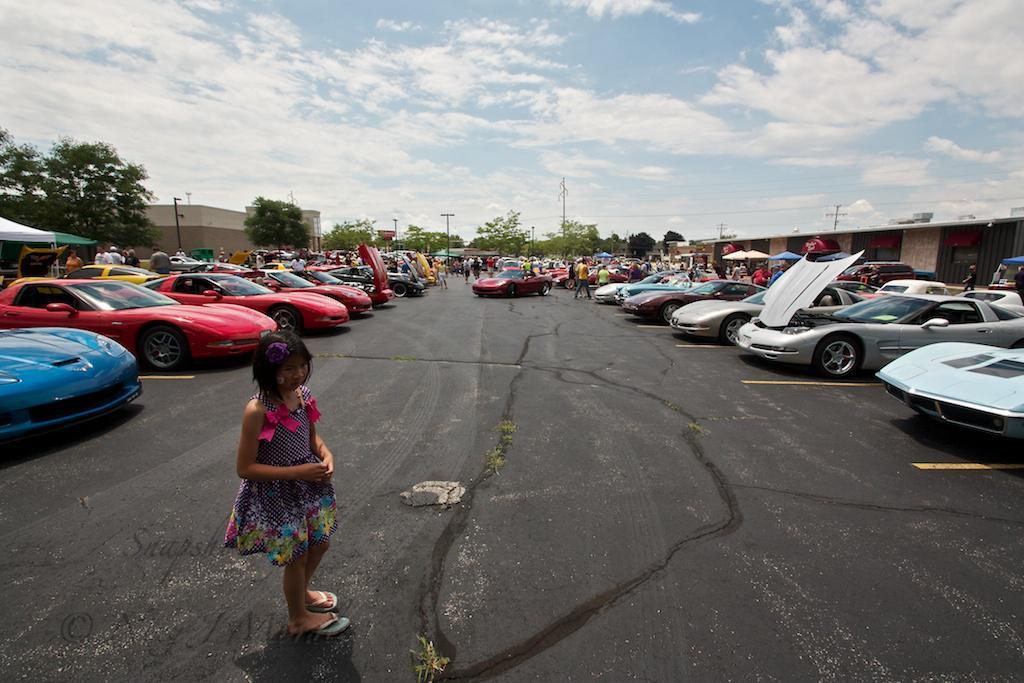What is the main subject in the front of the image? There is a person standing in the front of the image. What can be seen in the background of the image? In the background of the image, there are cars, persons, trees, buildings, and poles. How would you describe the sky in the image? The sky is cloudy in the image. What type of rock is being used as an appliance in the image? There is no rock or appliance present in the image. Can you see any birds in the image? There are no birds visible in the image. 